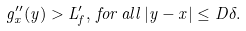<formula> <loc_0><loc_0><loc_500><loc_500>g ^ { \prime \prime } _ { x } ( y ) > L ^ { \prime } _ { f } , \, f o r \, a l l \, | y - x | \leq D \delta .</formula> 